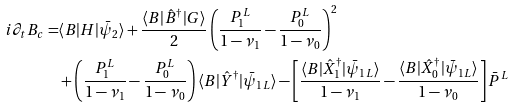Convert formula to latex. <formula><loc_0><loc_0><loc_500><loc_500>i \partial _ { t } B _ { c } = & \langle B | H | \bar { \psi } _ { 2 } \rangle + \frac { \langle B | \hat { B } ^ { \dag } | G \rangle } { 2 } \left ( \frac { P _ { 1 } ^ { L } } { 1 - \nu _ { 1 } } - \frac { P _ { 0 } ^ { L } } { 1 - \nu _ { 0 } } \right ) ^ { 2 } \\ & + \left ( \frac { P _ { 1 } ^ { L } } { 1 - \nu _ { 1 } } - \frac { P _ { 0 } ^ { L } } { 1 - \nu _ { 0 } } \right ) \langle B | \hat { Y } ^ { \dag } | \bar { \psi } _ { 1 L } \rangle - \left [ \frac { \langle B | \hat { X } _ { 1 } ^ { \dag } | \bar { \psi } _ { 1 L } \rangle } { 1 - \nu _ { 1 } } - \frac { \langle B | \hat { X } _ { 0 } ^ { \dag } | \bar { \psi } _ { 1 L } \rangle } { 1 - \nu _ { 0 } } \right ] \bar { P } ^ { L }</formula> 